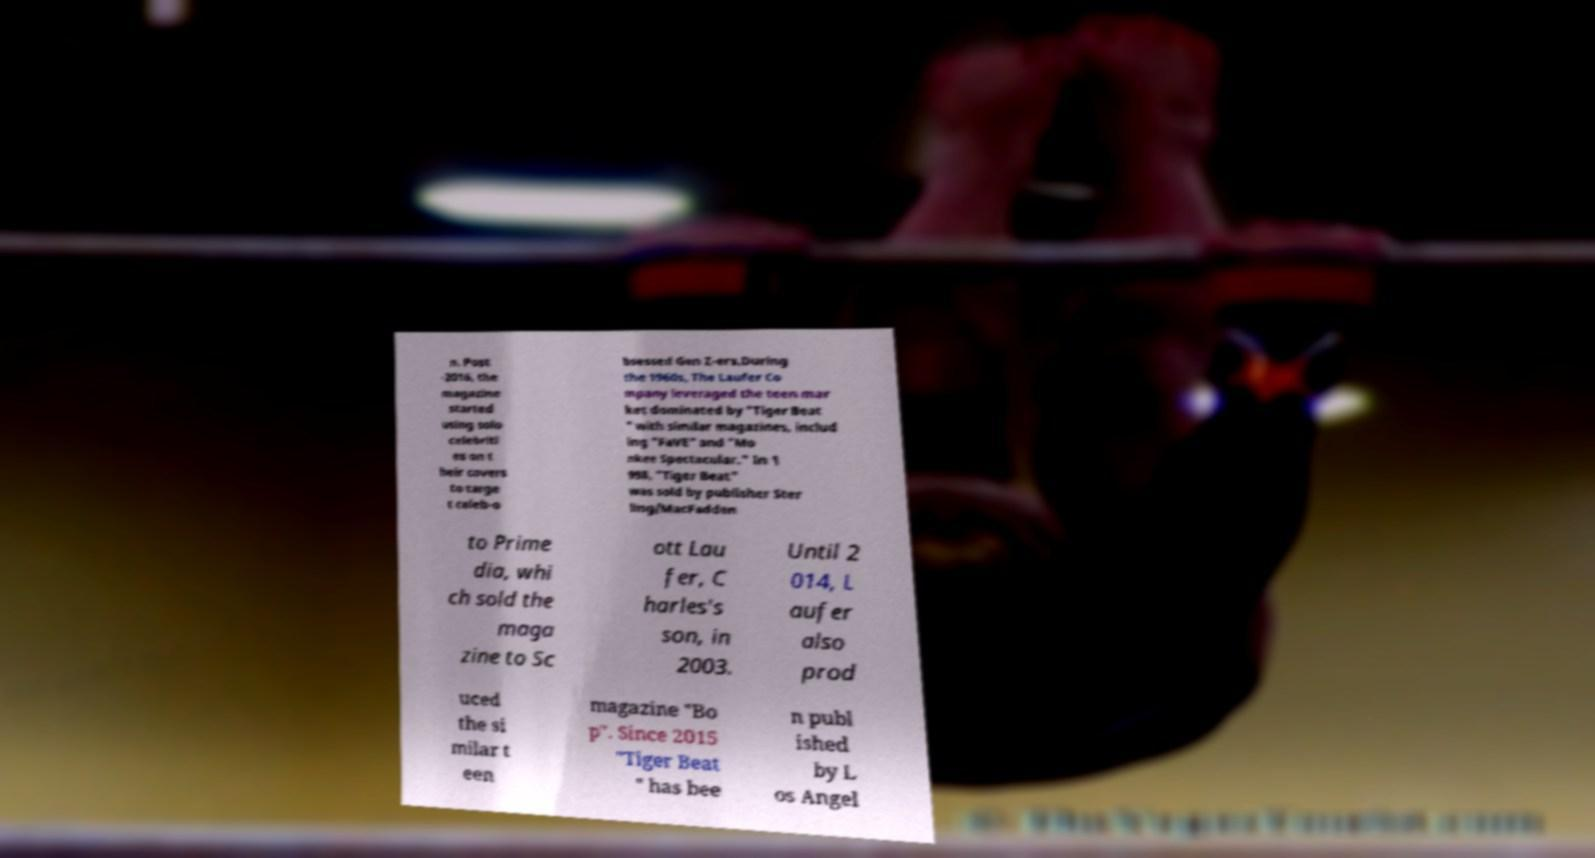I need the written content from this picture converted into text. Can you do that? n. Post -2016, the magazine started using solo celebriti es on t heir covers to targe t celeb-o bsessed Gen Z-ers.During the 1960s, The Laufer Co mpany leveraged the teen mar ket dominated by "Tiger Beat " with similar magazines, includ ing "FaVE" and "Mo nkee Spectacular." In 1 998, "Tiger Beat" was sold by publisher Ster ling/MacFadden to Prime dia, whi ch sold the maga zine to Sc ott Lau fer, C harles's son, in 2003. Until 2 014, L aufer also prod uced the si milar t een magazine "Bo p". Since 2015 "Tiger Beat " has bee n publ ished by L os Angel 